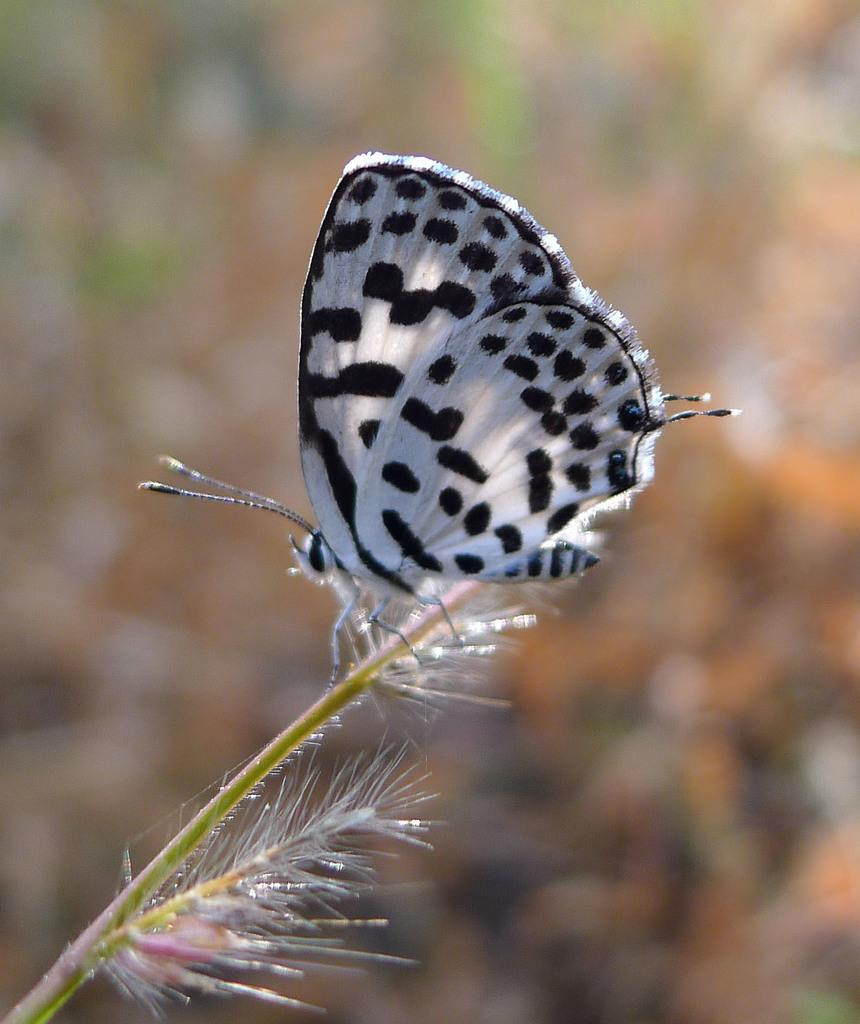What is the main subject of the image? There is a butterfly in the image. Where is the butterfly located? The butterfly is on a plant. Can you describe the background of the image? The background of the image is blurred. What type of wing is attached to the tub in the image? There is no tub or wing present in the image; it features a butterfly on a plant. 